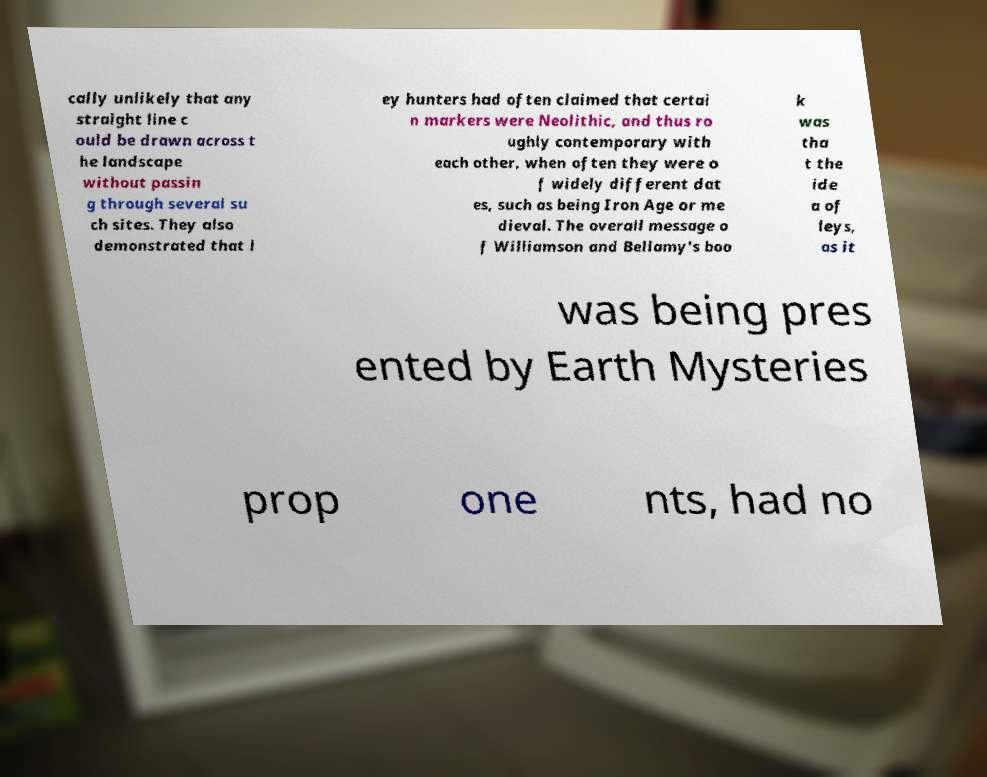Please identify and transcribe the text found in this image. cally unlikely that any straight line c ould be drawn across t he landscape without passin g through several su ch sites. They also demonstrated that l ey hunters had often claimed that certai n markers were Neolithic, and thus ro ughly contemporary with each other, when often they were o f widely different dat es, such as being Iron Age or me dieval. The overall message o f Williamson and Bellamy's boo k was tha t the ide a of leys, as it was being pres ented by Earth Mysteries prop one nts, had no 